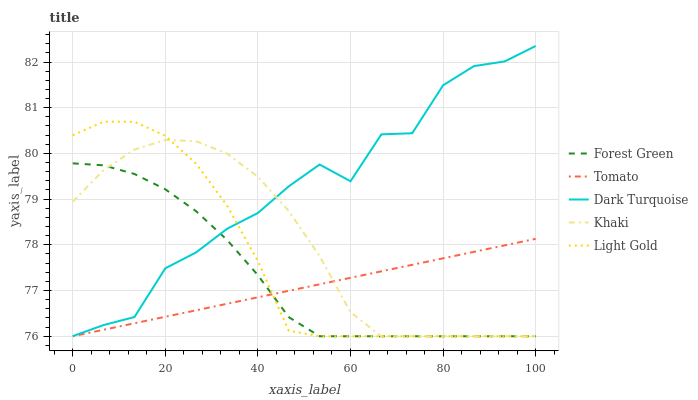Does Tomato have the minimum area under the curve?
Answer yes or no. Yes. Does Dark Turquoise have the maximum area under the curve?
Answer yes or no. Yes. Does Forest Green have the minimum area under the curve?
Answer yes or no. No. Does Forest Green have the maximum area under the curve?
Answer yes or no. No. Is Tomato the smoothest?
Answer yes or no. Yes. Is Dark Turquoise the roughest?
Answer yes or no. Yes. Is Forest Green the smoothest?
Answer yes or no. No. Is Forest Green the roughest?
Answer yes or no. No. Does Tomato have the lowest value?
Answer yes or no. Yes. Does Dark Turquoise have the lowest value?
Answer yes or no. No. Does Dark Turquoise have the highest value?
Answer yes or no. Yes. Does Forest Green have the highest value?
Answer yes or no. No. Is Tomato less than Dark Turquoise?
Answer yes or no. Yes. Is Dark Turquoise greater than Tomato?
Answer yes or no. Yes. Does Khaki intersect Dark Turquoise?
Answer yes or no. Yes. Is Khaki less than Dark Turquoise?
Answer yes or no. No. Is Khaki greater than Dark Turquoise?
Answer yes or no. No. Does Tomato intersect Dark Turquoise?
Answer yes or no. No. 